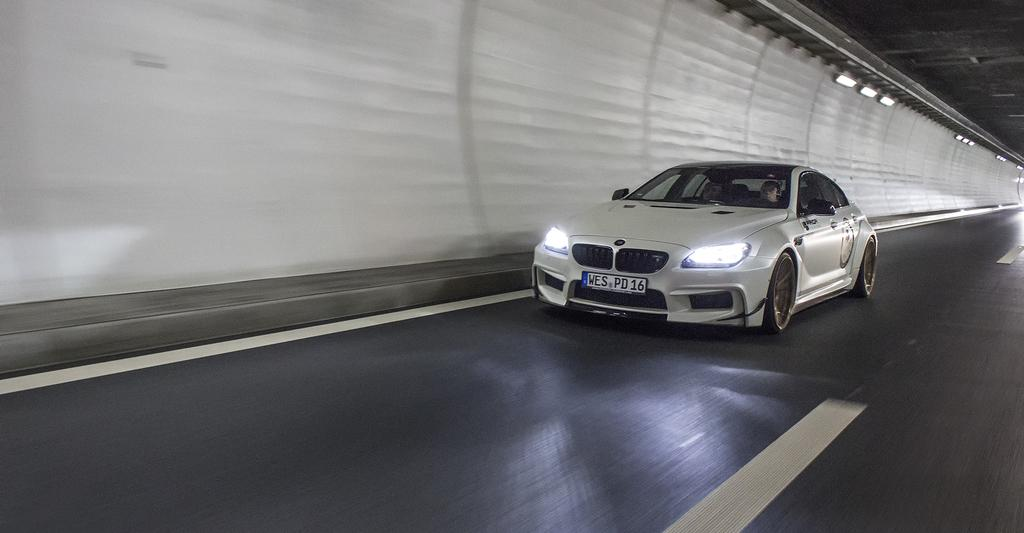What type of vehicle is in the image? There is a white car in the image. What is at the bottom of the image? There is a road at the bottom of the image. What is on the left side of the image? There is a wall with lights on the left side of the image. What is visible at the top of the image? There is a roof visible at the top of the image. Can you measure the depth of the ocean in the image? There is no ocean present in the image, so it is not possible to measure its depth. 